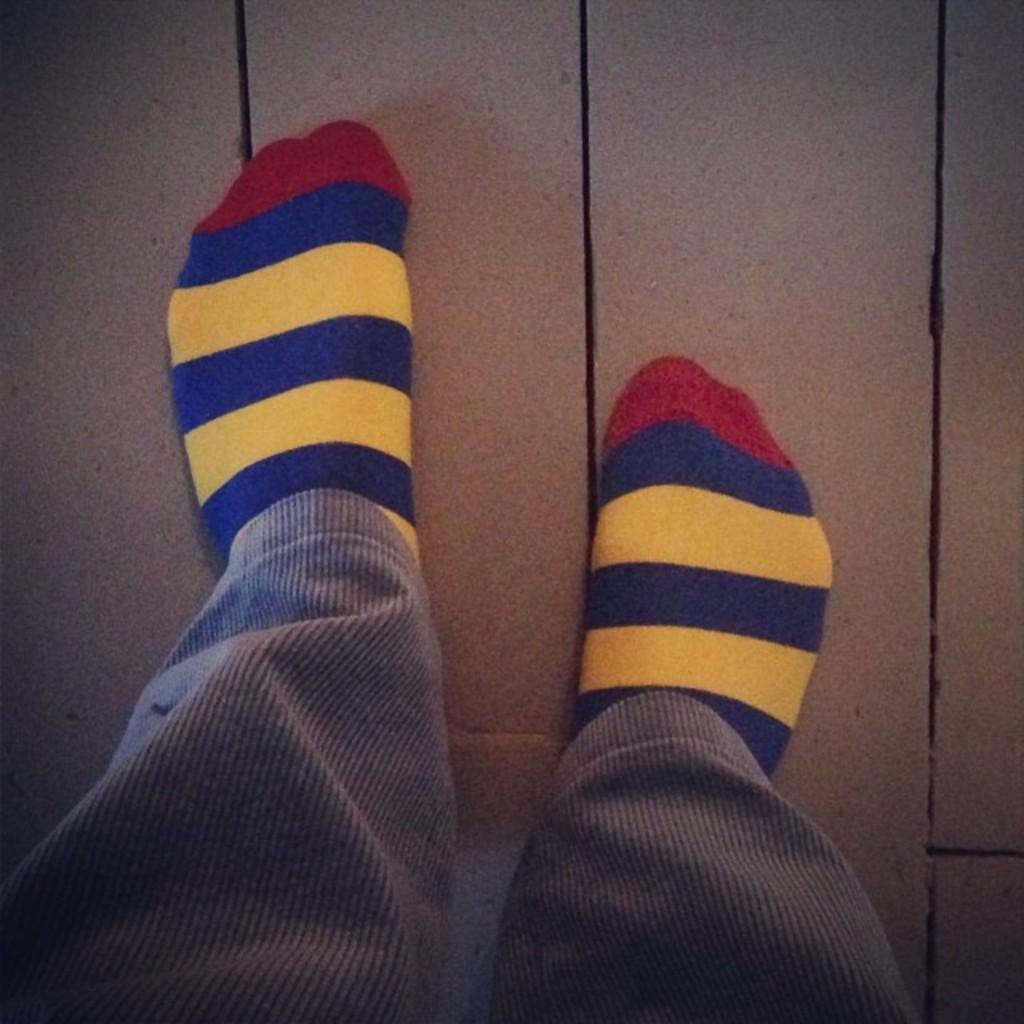Please provide a concise description of this image. In the center of the image we can see two human legs wearing colorful socks. 